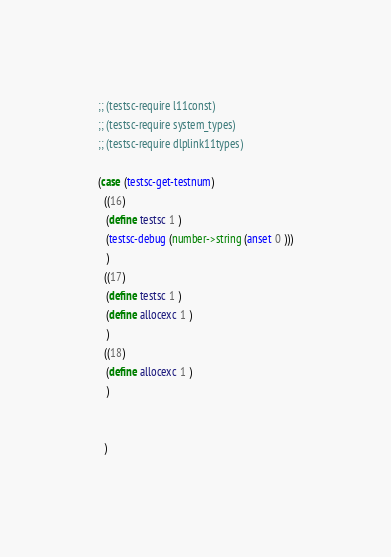Convert code to text. <code><loc_0><loc_0><loc_500><loc_500><_Scheme_>
;; (testsc-require l11const)
;; (testsc-require system_types)
;; (testsc-require dlplink11types)

(case (testsc-get-testnum)
  ((16)
   (define testsc 1 )
   (testsc-debug (number->string (anset 0 )))
   )         
  ((17)
   (define testsc 1 )
   (define allocexc 1 )
   )         
  ((18)
   (define allocexc 1 )
   )         


  )

</code> 